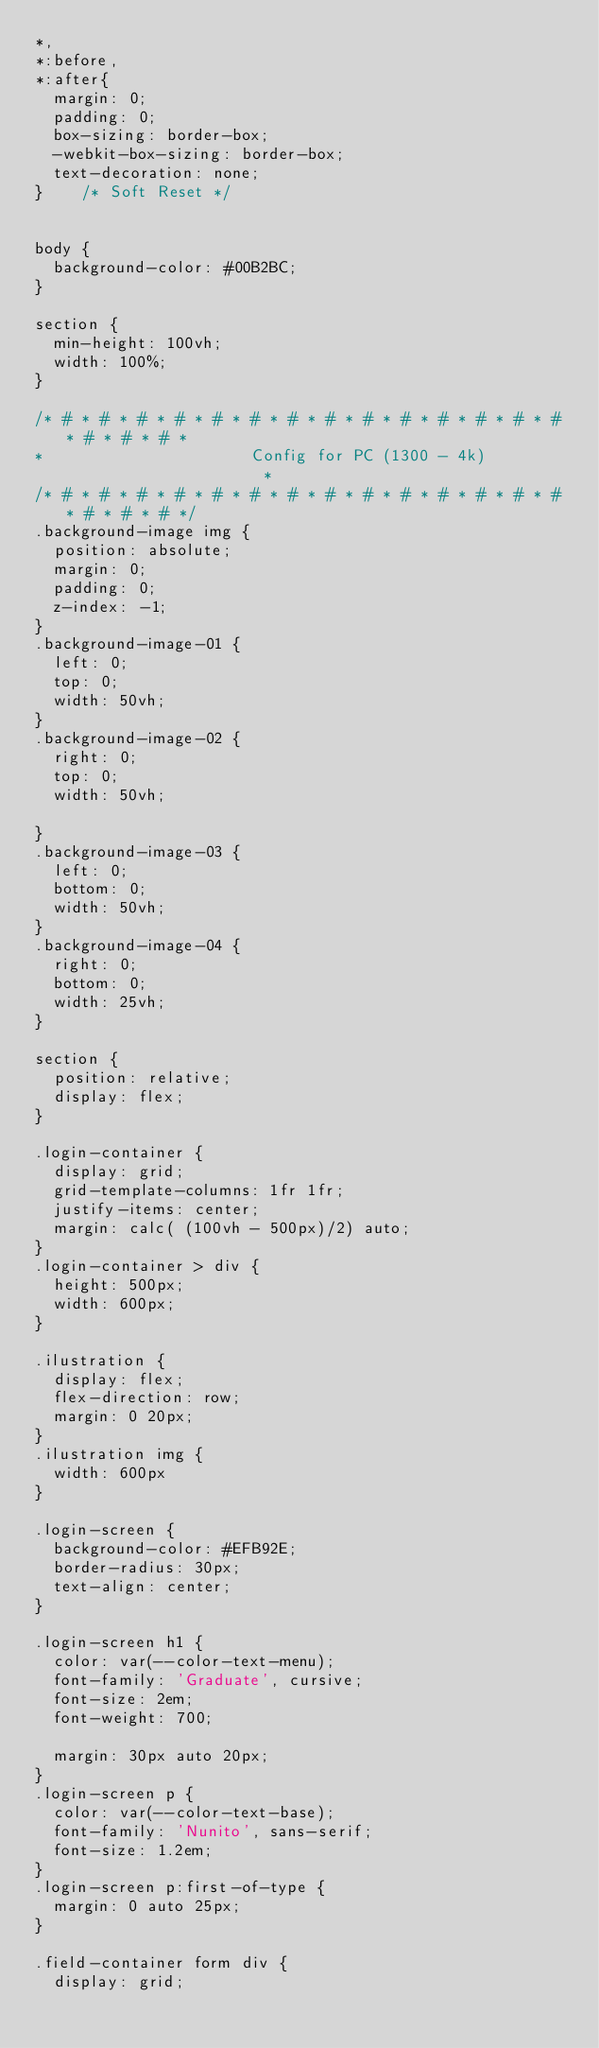Convert code to text. <code><loc_0><loc_0><loc_500><loc_500><_CSS_>*,
*:before,
*:after{
  margin: 0;
  padding: 0;
  box-sizing: border-box;
  -webkit-box-sizing: border-box;
  text-decoration: none;
}    /* Soft Reset */


body {
  background-color: #00B2BC;
}

section {
  min-height: 100vh;
  width: 100%;
}

/* # * # * # * # * # * # * # * # * # * # * # * # * # * # * # * # * # *
*                      Config for PC (1300 - 4k)                      *
/* # * # * # * # * # * # * # * # * # * # * # * # * # * # * # * # * # */
.background-image img {
  position: absolute;
  margin: 0;
  padding: 0;
  z-index: -1;
}
.background-image-01 {
  left: 0;
  top: 0;
  width: 50vh;
}
.background-image-02 {
  right: 0;
  top: 0;
  width: 50vh;

}
.background-image-03 {
  left: 0;
  bottom: 0;
  width: 50vh;
}
.background-image-04 {
  right: 0;
  bottom: 0;
  width: 25vh;
}

section {
  position: relative;
  display: flex;
}

.login-container {
  display: grid;
  grid-template-columns: 1fr 1fr;
  justify-items: center;
  margin: calc( (100vh - 500px)/2) auto;
}
.login-container > div {
  height: 500px;
  width: 600px;
}

.ilustration {
  display: flex;
  flex-direction: row;
  margin: 0 20px;
}
.ilustration img {
  width: 600px
}

.login-screen {
  background-color: #EFB92E;
  border-radius: 30px;
  text-align: center;
}

.login-screen h1 {
  color: var(--color-text-menu);
  font-family: 'Graduate', cursive;
  font-size: 2em;
  font-weight: 700;
  
  margin: 30px auto 20px;
}
.login-screen p {
  color: var(--color-text-base);
  font-family: 'Nunito', sans-serif;
  font-size: 1.2em;
}
.login-screen p:first-of-type {
  margin: 0 auto 25px;
}

.field-container form div {
  display: grid; </code> 